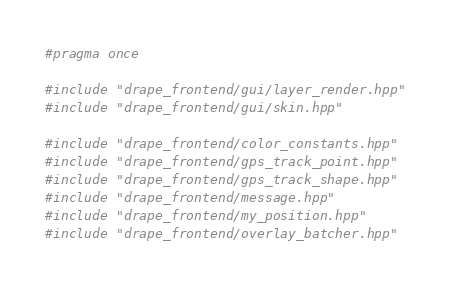<code> <loc_0><loc_0><loc_500><loc_500><_C++_>#pragma once

#include "drape_frontend/gui/layer_render.hpp"
#include "drape_frontend/gui/skin.hpp"

#include "drape_frontend/color_constants.hpp"
#include "drape_frontend/gps_track_point.hpp"
#include "drape_frontend/gps_track_shape.hpp"
#include "drape_frontend/message.hpp"
#include "drape_frontend/my_position.hpp"
#include "drape_frontend/overlay_batcher.hpp"</code> 